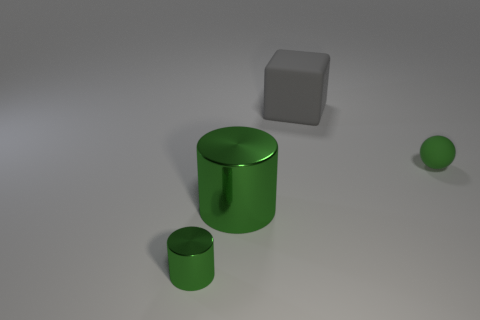What material is the green object in front of the large object in front of the large thing behind the small matte sphere?
Your response must be concise. Metal. Do the big cylinder and the large block have the same material?
Your answer should be very brief. No. How many balls are large green metal objects or large gray objects?
Provide a short and direct response. 0. The large thing that is on the left side of the big matte block is what color?
Give a very brief answer. Green. What number of rubber things are big things or gray cylinders?
Your response must be concise. 1. What is the material of the large thing that is in front of the big thing that is behind the small sphere?
Give a very brief answer. Metal. What is the material of the large thing that is the same color as the tiny matte ball?
Give a very brief answer. Metal. The matte ball has what color?
Your answer should be very brief. Green. Is there a small green object that is left of the small thing that is to the right of the gray object?
Give a very brief answer. Yes. What is the green ball made of?
Make the answer very short. Rubber. 